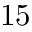Convert formula to latex. <formula><loc_0><loc_0><loc_500><loc_500>1 5</formula> 